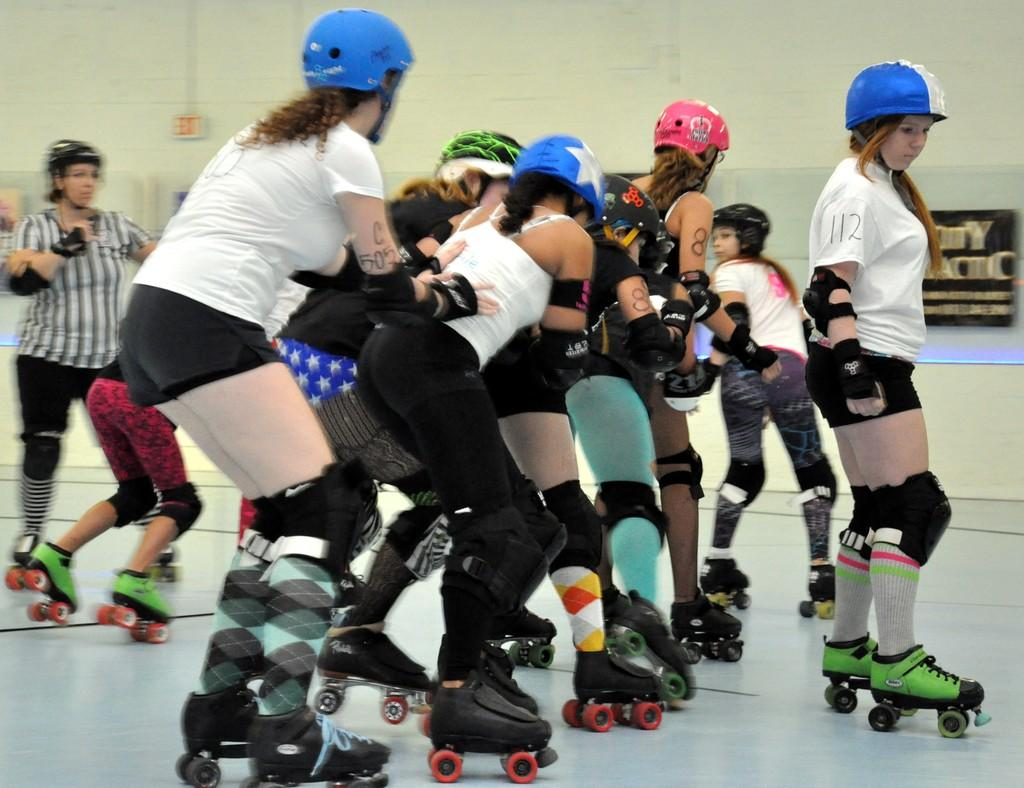How many people are in the image? There is a group of people in the image. What are the people doing in the image? The people are skating on the floor. What can be seen in the background of the image? There is a wall, a fence, and a board in the background of the image. Can you describe the lighting in the image? The image was likely taken during the day, as there is sufficient light to see the people and the surroundings clearly. What type of foot is visible on the board in the image? There is no foot visible on the board in the image. What kind of beef is being served at the skating event in the image? There is no mention of beef or any food in the image; it only shows people skating on the floor. 